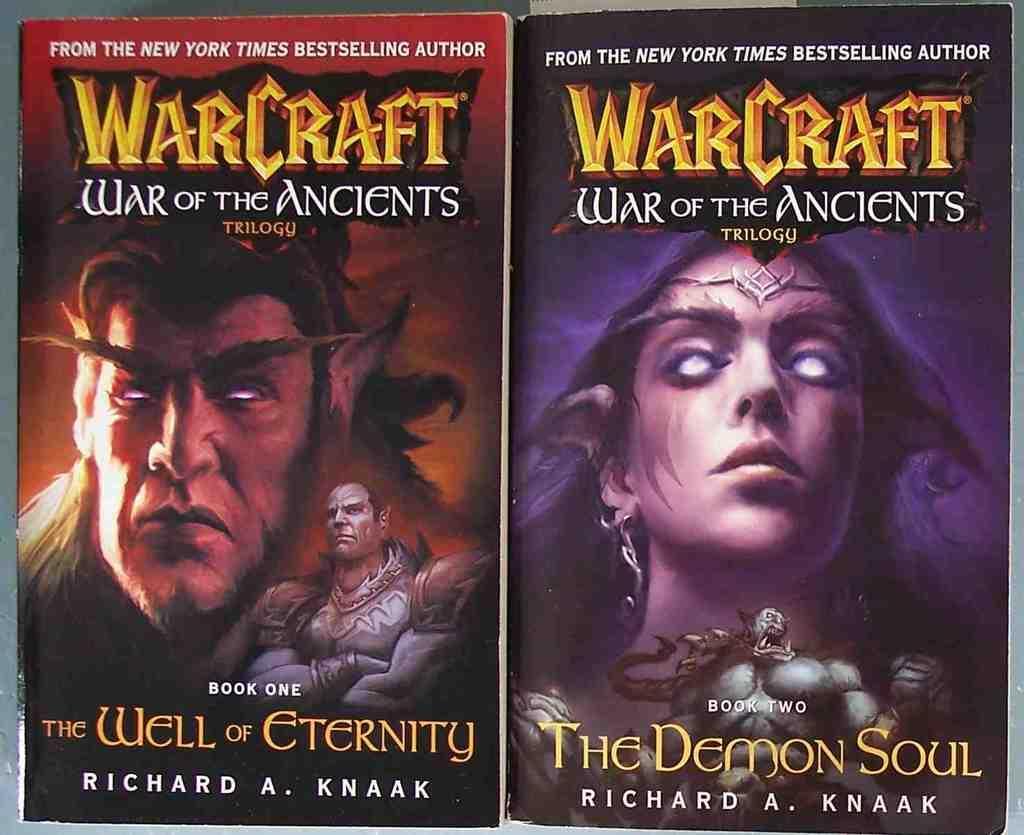Could you give a brief overview of what you see in this image? In this image in the center there are two posters, and on the posters there are two persons and some text. 